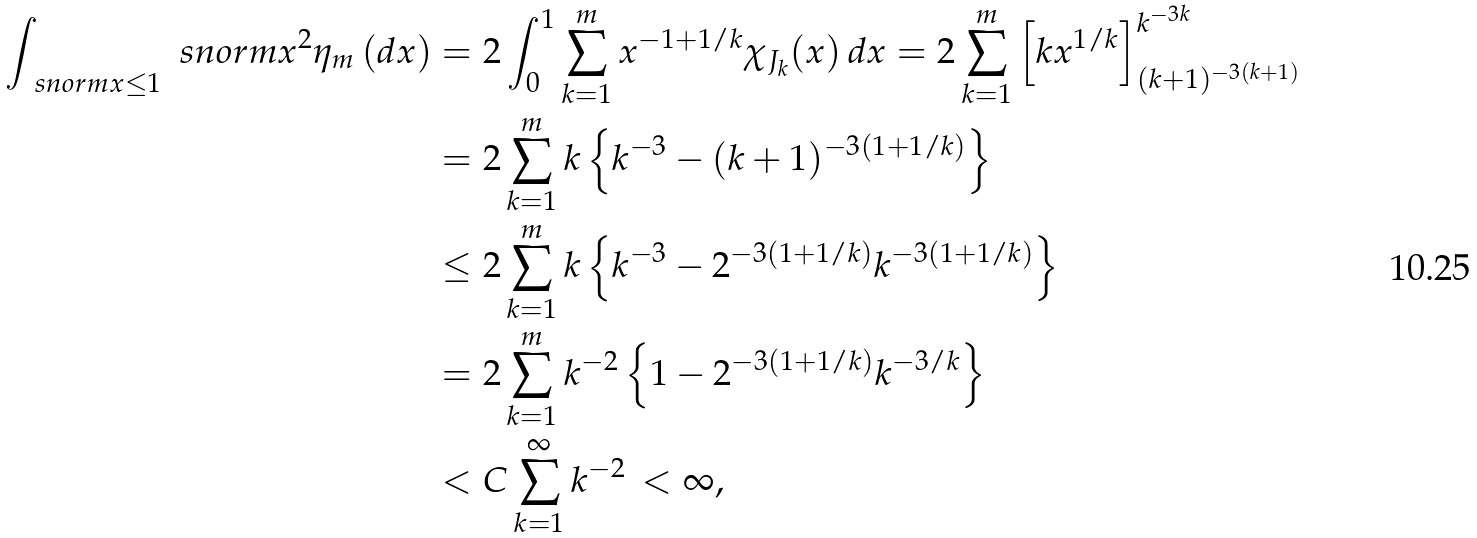<formula> <loc_0><loc_0><loc_500><loc_500>\int _ { \ s n o r m { x } \leq 1 } \ s n o r m { x } ^ { 2 } \eta _ { m } \, ( d x ) & = 2 \int _ { 0 } ^ { 1 } \sum _ { k = 1 } ^ { m } x ^ { - 1 + 1 / k } \chi _ { J _ { k } } ( x ) \, d x = 2 \sum _ { k = 1 } ^ { m } \left [ k x ^ { 1 / k } \right ] _ { ( k + 1 ) ^ { - 3 ( k + 1 ) } } ^ { k ^ { - 3 k } } \\ & = 2 \sum _ { k = 1 } ^ { m } k \left \{ k ^ { - 3 } - ( k + 1 ) ^ { - 3 ( 1 + 1 / k ) } \right \} \\ & \leq 2 \sum _ { k = 1 } ^ { m } k \left \{ k ^ { - 3 } - 2 ^ { - 3 ( 1 + 1 / k ) } k ^ { - 3 ( 1 + 1 / k ) } \right \} \\ & = 2 \sum _ { k = 1 } ^ { m } k ^ { - 2 } \left \{ 1 - 2 ^ { - 3 ( 1 + 1 / k ) } k ^ { - 3 / k } \right \} \\ & < C \sum _ { k = 1 } ^ { \infty } k ^ { - 2 } \, < \infty ,</formula> 